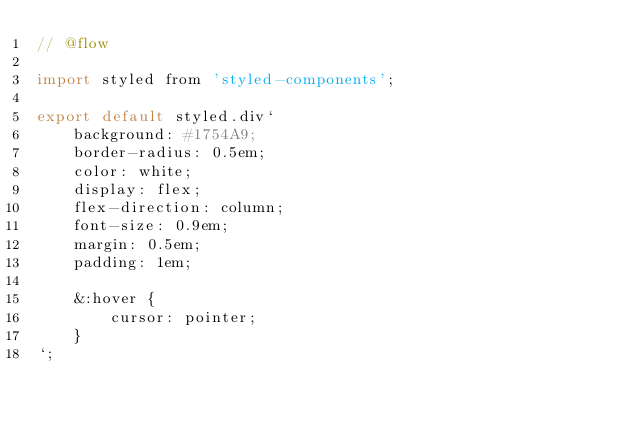<code> <loc_0><loc_0><loc_500><loc_500><_JavaScript_>// @flow

import styled from 'styled-components';

export default styled.div`
    background: #1754A9;
    border-radius: 0.5em;
    color: white;
    display: flex;
    flex-direction: column;
    font-size: 0.9em;
    margin: 0.5em;
    padding: 1em;
    
    &:hover {
        cursor: pointer;
    }
`;
</code> 